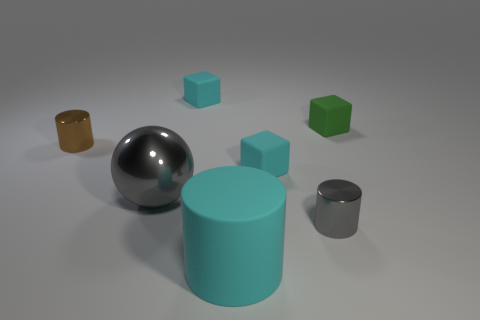Add 1 small purple spheres. How many objects exist? 8 Subtract all balls. How many objects are left? 6 Add 2 cyan rubber blocks. How many cyan rubber blocks exist? 4 Subtract 1 gray balls. How many objects are left? 6 Subtract all big shiny balls. Subtract all yellow rubber cylinders. How many objects are left? 6 Add 1 big cylinders. How many big cylinders are left? 2 